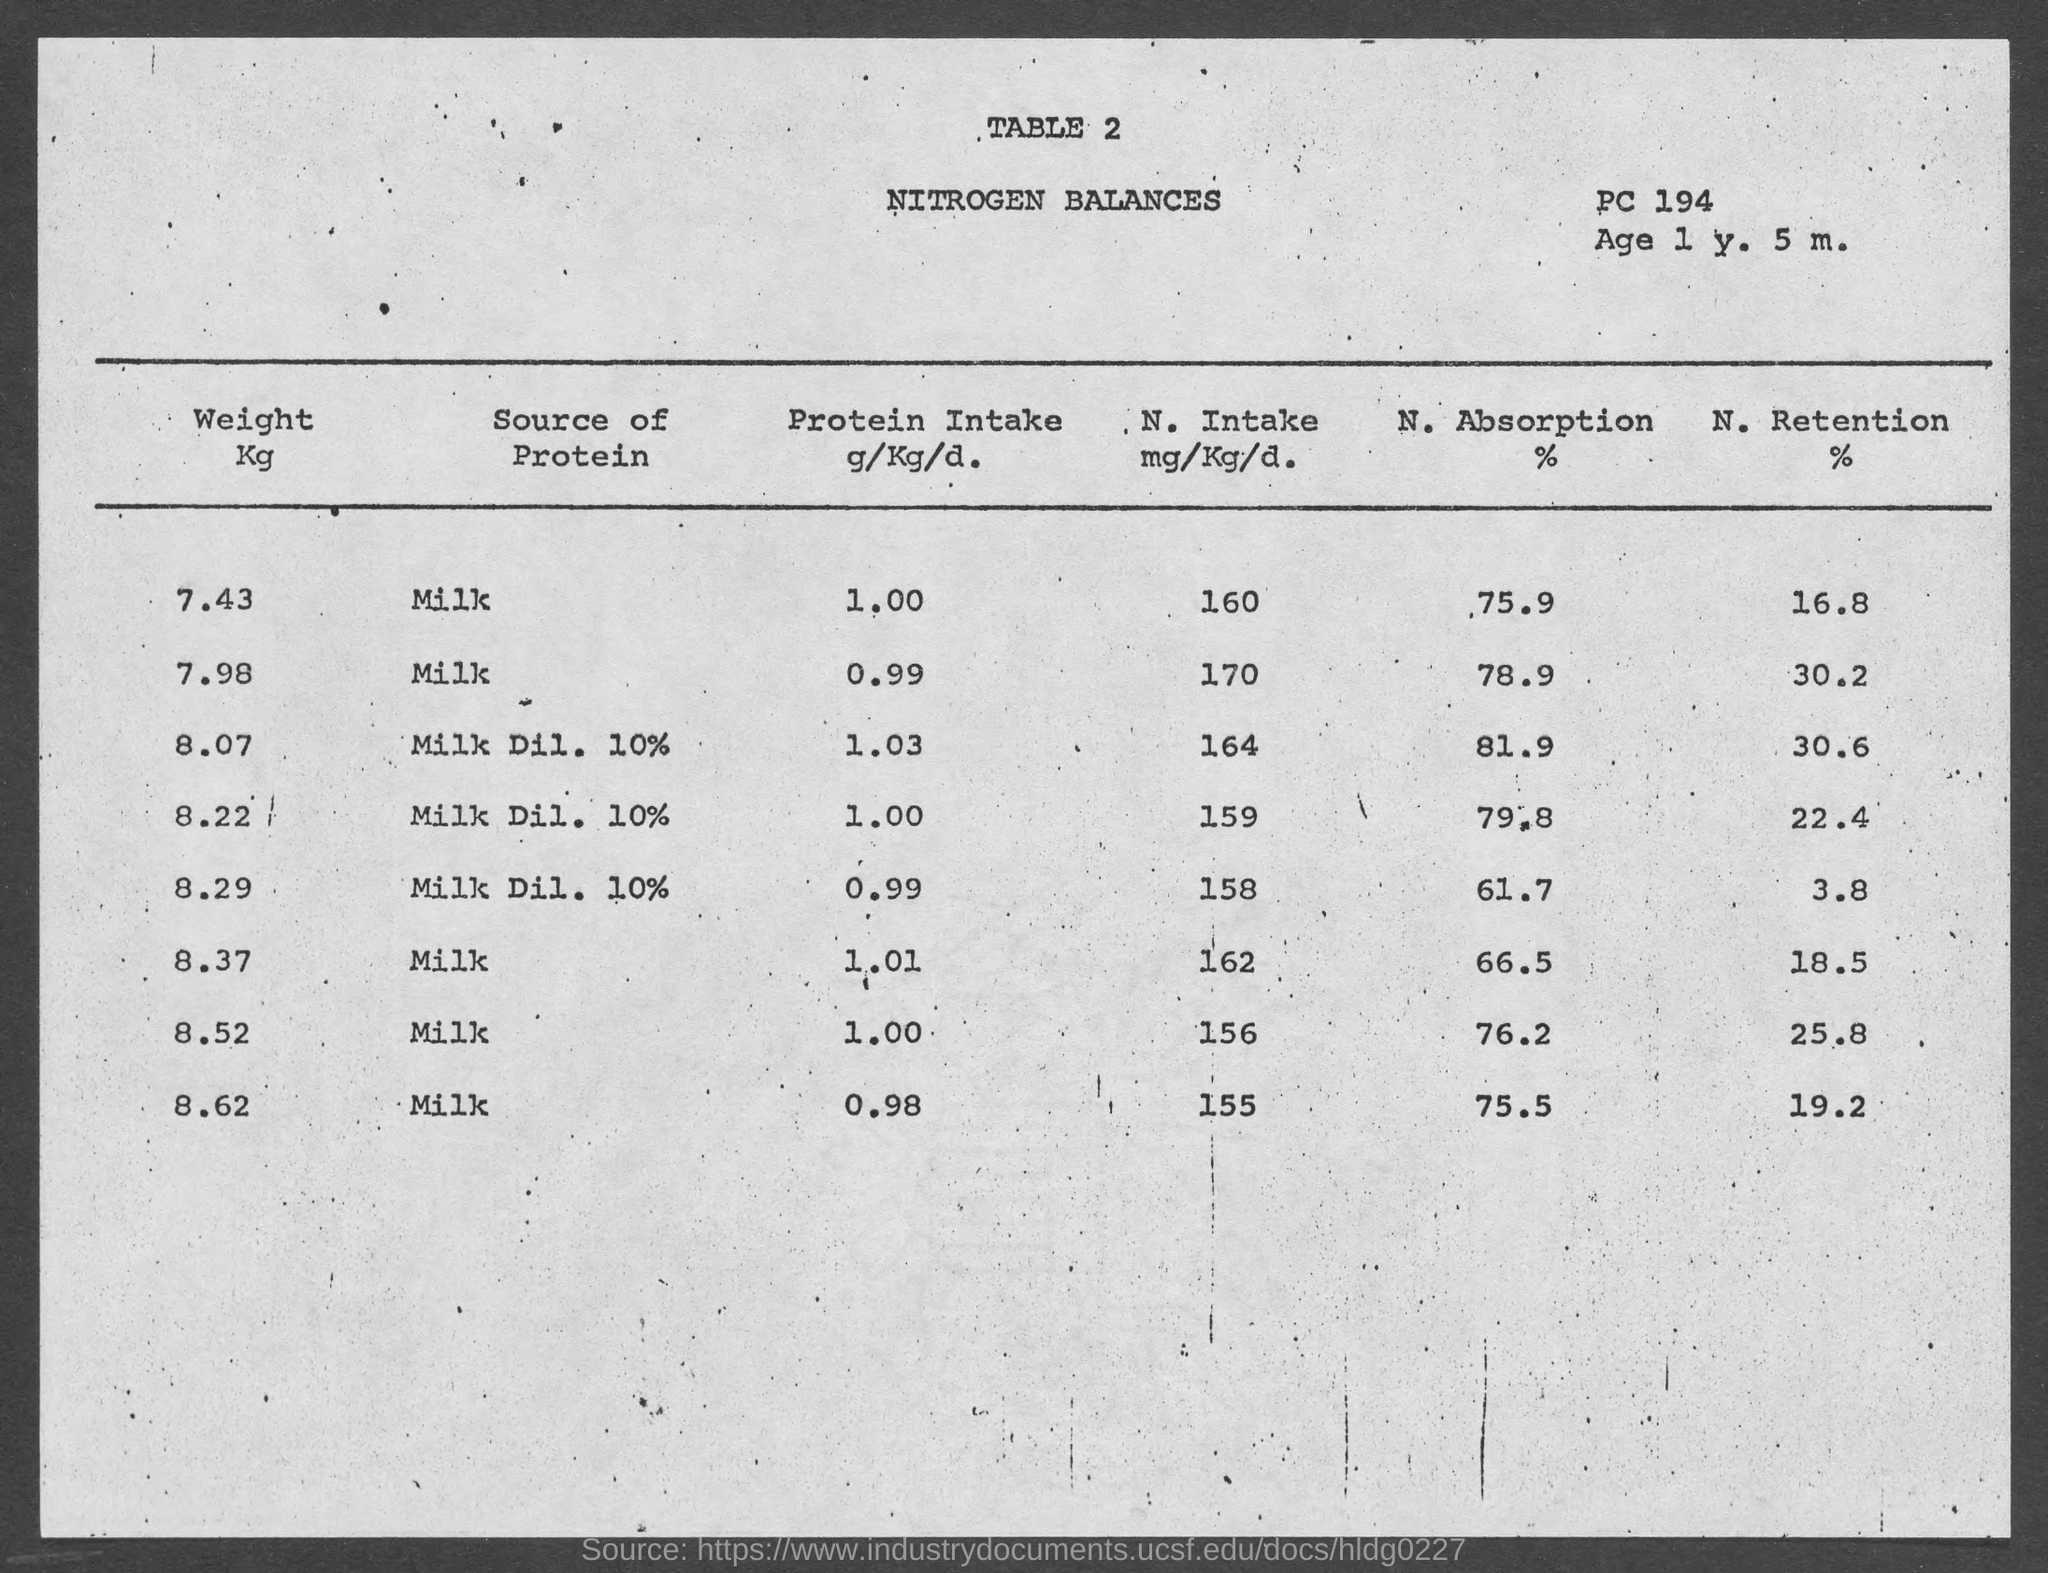What is the title of the table 2?
Your answer should be very brief. Nitrogen Balances. 